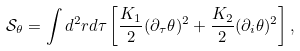<formula> <loc_0><loc_0><loc_500><loc_500>\mathcal { S } _ { \theta } = \int d ^ { 2 } r d \tau \left [ \frac { K _ { 1 } } { 2 } ( \partial _ { \tau } \theta ) ^ { 2 } + \frac { K _ { 2 } } { 2 } ( \partial _ { i } \theta ) ^ { 2 } \right ] ,</formula> 